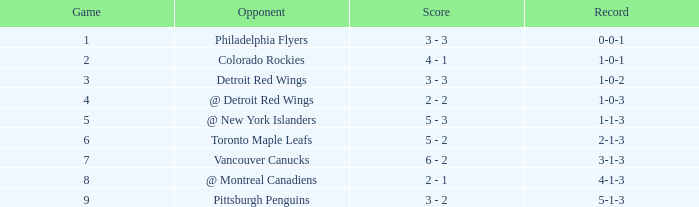Identify the score for a game beyond 6 and before october 2 6 - 2. 